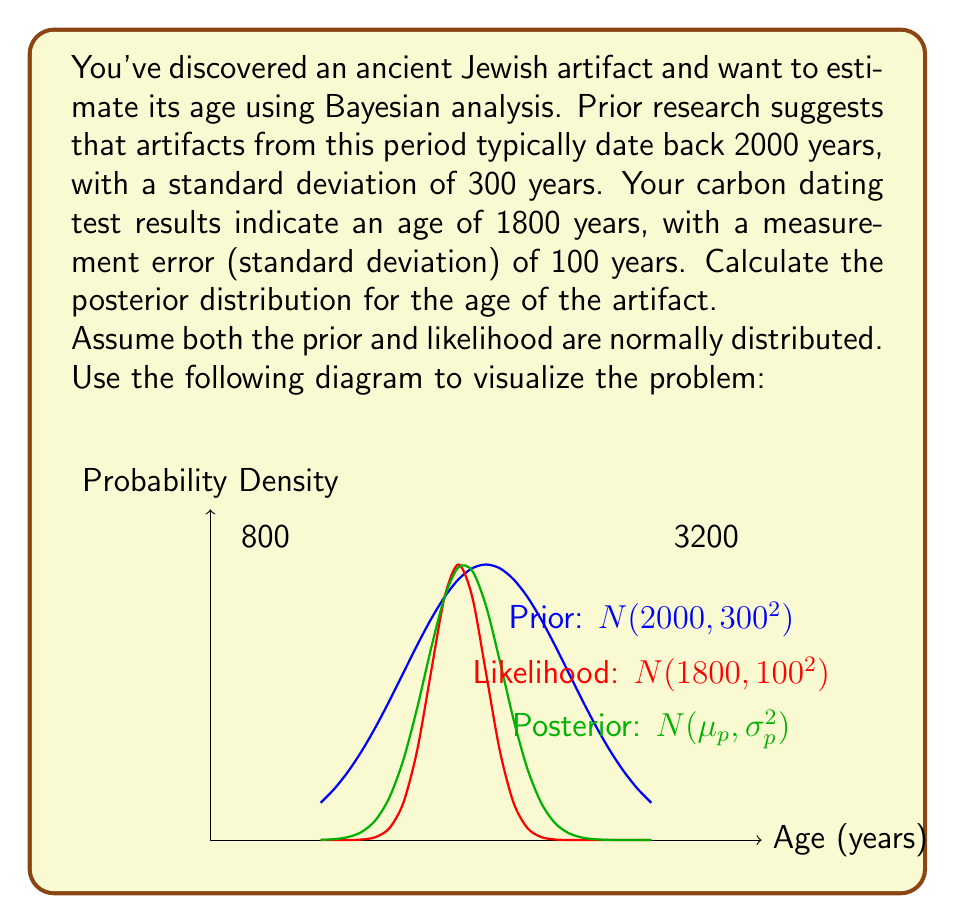Can you answer this question? To solve this problem, we'll use the Bayesian updating formula for normally distributed prior and likelihood. Let's follow these steps:

1) Define our variables:
   $\mu_0 = 2000$ (prior mean)
   $\sigma_0 = 300$ (prior standard deviation)
   $\mu_x = 1800$ (likelihood mean)
   $\sigma_x = 100$ (likelihood standard deviation)

2) The posterior distribution will also be normal, with parameters $\mu_p$ and $\sigma_p^2$.

3) Calculate the posterior mean $\mu_p$:
   $$\mu_p = \frac{\frac{\mu_0}{\sigma_0^2} + \frac{\mu_x}{\sigma_x^2}}{\frac{1}{\sigma_0^2} + \frac{1}{\sigma_x^2}}$$

   $$\mu_p = \frac{\frac{2000}{300^2} + \frac{1800}{100^2}}{\frac{1}{300^2} + \frac{1}{100^2}}$$

   $$\mu_p = \frac{0.0222 + 0.18}{0.0000111 + 0.0001} = \frac{0.2022}{0.0001111} \approx 1820.16$$

4) Calculate the posterior variance $\sigma_p^2$:
   $$\sigma_p^2 = \frac{1}{\frac{1}{\sigma_0^2} + \frac{1}{\sigma_x^2}}$$

   $$\sigma_p^2 = \frac{1}{\frac{1}{300^2} + \frac{1}{100^2}} = \frac{1}{0.0001111} \approx 9001.80$$

5) Take the square root to get the posterior standard deviation:
   $$\sigma_p = \sqrt{9001.80} \approx 94.88$$

Therefore, the posterior distribution is approximately $N(1820.16, 94.88^2)$.
Answer: $N(1820.16, 94.88^2)$ 